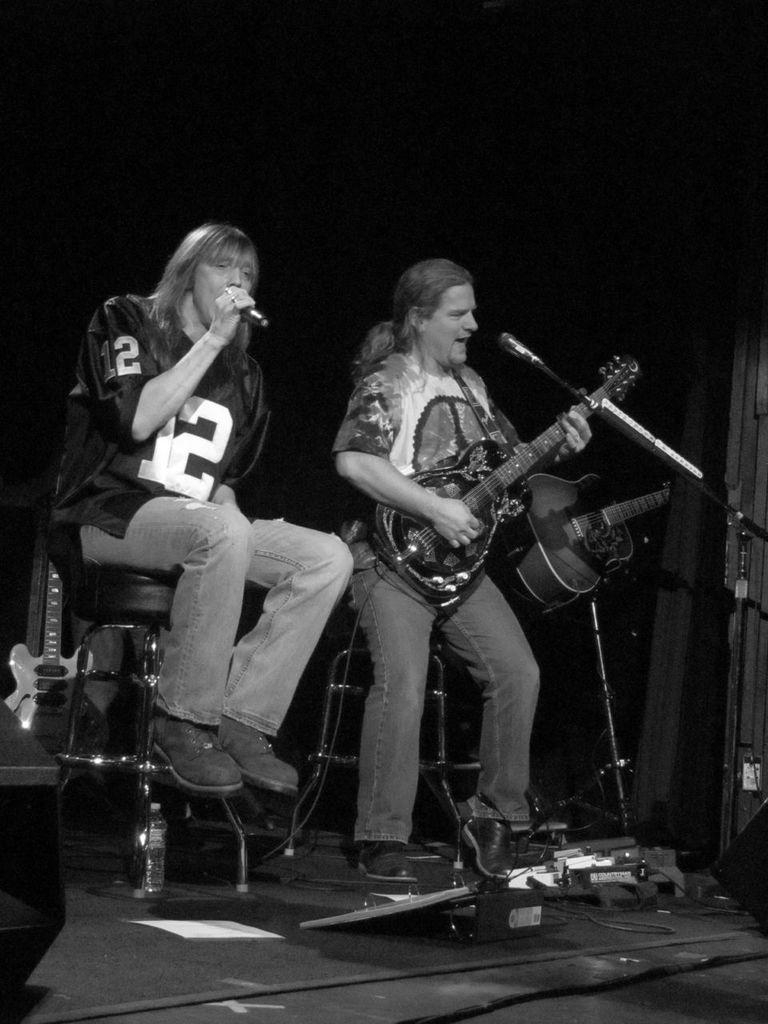Describe this image in one or two sentences. In the image we can see there is a man who is standing and holding guitar in his hand and another person is sitting and he is holding mic in his hand and the image is in black and white colour and there are other guitars on the stage. 